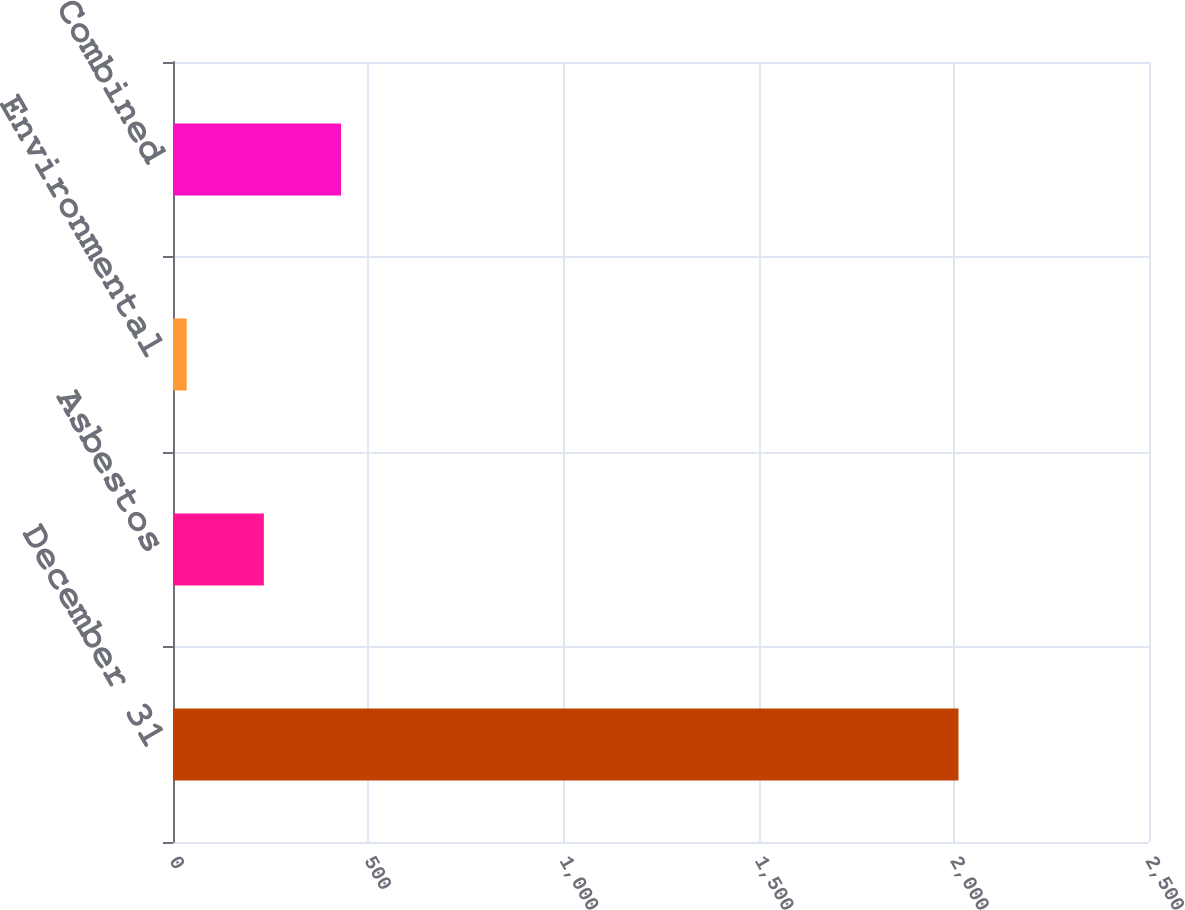<chart> <loc_0><loc_0><loc_500><loc_500><bar_chart><fcel>December 31<fcel>Asbestos<fcel>Environmental<fcel>Combined<nl><fcel>2012<fcel>232.7<fcel>35<fcel>430.4<nl></chart> 